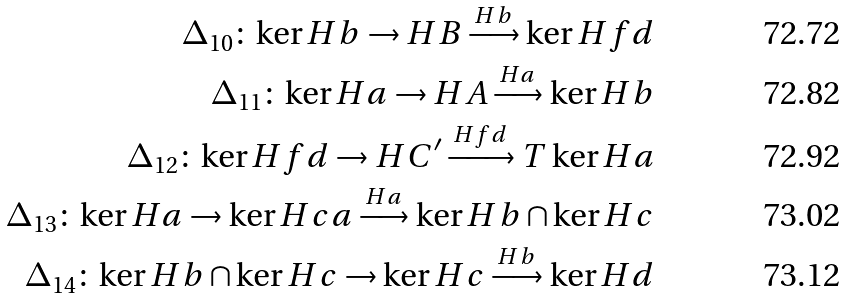Convert formula to latex. <formula><loc_0><loc_0><loc_500><loc_500>\Delta _ { 1 0 } \colon \ker H b \to H B \xrightarrow { H b } \ker H f d \\ \Delta _ { 1 1 } \colon \ker H a \to H A \xrightarrow { H a } \ker H b \\ \Delta _ { 1 2 } \colon \ker H f d \to H C ^ { \prime } \xrightarrow { H f d } T \ker H a \\ \Delta _ { 1 3 } \colon \ker H a \to \ker H c a \xrightarrow { H a } \ker H b \cap \ker H c \\ \Delta _ { 1 4 } \colon \ker H b \cap \ker H c \to \ker H c \xrightarrow { H b } \ker H d</formula> 